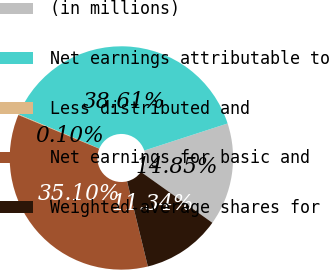<chart> <loc_0><loc_0><loc_500><loc_500><pie_chart><fcel>(in millions)<fcel>Net earnings attributable to<fcel>Less distributed and<fcel>Net earnings for basic and<fcel>Weighted-average shares for<nl><fcel>14.85%<fcel>38.61%<fcel>0.1%<fcel>35.1%<fcel>11.34%<nl></chart> 